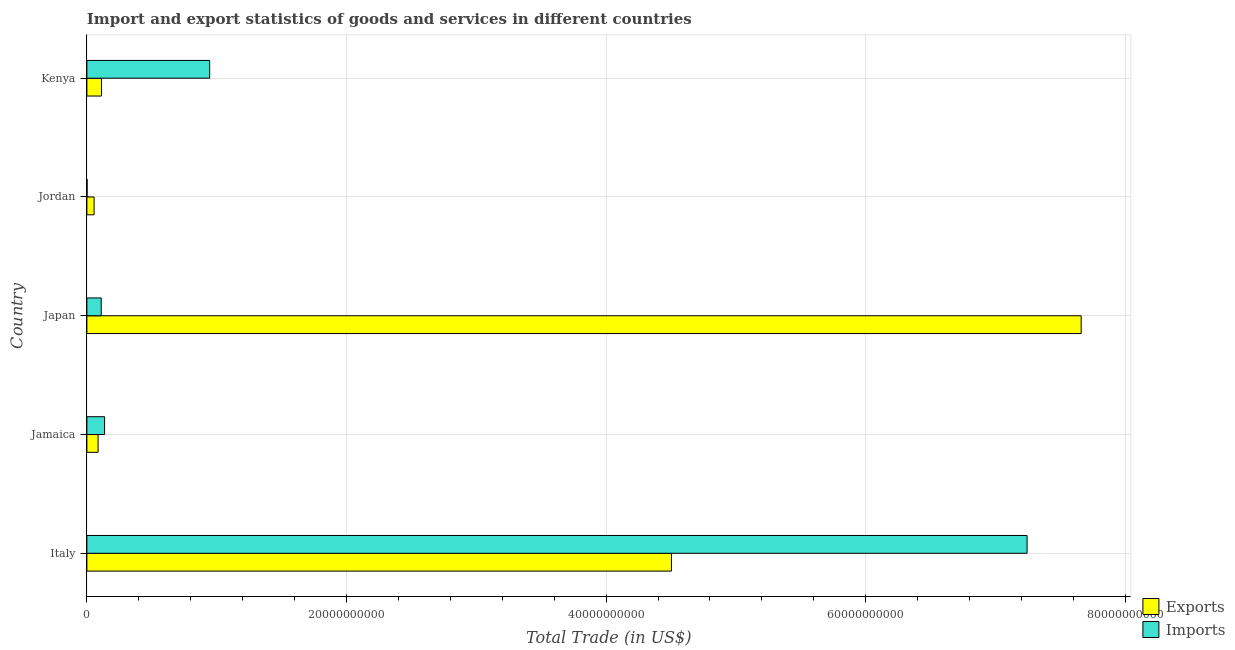How many different coloured bars are there?
Your answer should be compact. 2. What is the label of the 3rd group of bars from the top?
Offer a very short reply. Japan. What is the imports of goods and services in Jordan?
Ensure brevity in your answer.  1.47e+07. Across all countries, what is the maximum export of goods and services?
Offer a terse response. 7.66e+1. Across all countries, what is the minimum imports of goods and services?
Your answer should be compact. 1.47e+07. In which country was the imports of goods and services maximum?
Ensure brevity in your answer.  Italy. In which country was the export of goods and services minimum?
Keep it short and to the point. Jordan. What is the total imports of goods and services in the graph?
Provide a short and direct response. 8.44e+1. What is the difference between the imports of goods and services in Japan and that in Kenya?
Offer a very short reply. -8.36e+09. What is the difference between the export of goods and services in Japan and the imports of goods and services in Italy?
Offer a very short reply. 4.17e+09. What is the average export of goods and services per country?
Ensure brevity in your answer.  2.48e+1. What is the difference between the imports of goods and services and export of goods and services in Japan?
Give a very brief answer. -7.55e+1. In how many countries, is the imports of goods and services greater than 60000000000 US$?
Give a very brief answer. 1. What is the ratio of the imports of goods and services in Italy to that in Japan?
Ensure brevity in your answer.  65.65. Is the difference between the imports of goods and services in Jamaica and Kenya greater than the difference between the export of goods and services in Jamaica and Kenya?
Ensure brevity in your answer.  No. What is the difference between the highest and the second highest imports of goods and services?
Keep it short and to the point. 6.30e+1. What is the difference between the highest and the lowest imports of goods and services?
Provide a short and direct response. 7.24e+1. In how many countries, is the export of goods and services greater than the average export of goods and services taken over all countries?
Offer a very short reply. 2. What does the 2nd bar from the top in Italy represents?
Your answer should be very brief. Exports. What does the 2nd bar from the bottom in Jamaica represents?
Provide a short and direct response. Imports. Are all the bars in the graph horizontal?
Give a very brief answer. Yes. How many countries are there in the graph?
Your response must be concise. 5. Are the values on the major ticks of X-axis written in scientific E-notation?
Provide a succinct answer. No. Where does the legend appear in the graph?
Make the answer very short. Bottom right. How are the legend labels stacked?
Ensure brevity in your answer.  Vertical. What is the title of the graph?
Provide a short and direct response. Import and export statistics of goods and services in different countries. Does "Boys" appear as one of the legend labels in the graph?
Ensure brevity in your answer.  No. What is the label or title of the X-axis?
Keep it short and to the point. Total Trade (in US$). What is the Total Trade (in US$) of Exports in Italy?
Your response must be concise. 4.50e+1. What is the Total Trade (in US$) in Imports in Italy?
Your response must be concise. 7.24e+1. What is the Total Trade (in US$) in Exports in Jamaica?
Make the answer very short. 8.62e+08. What is the Total Trade (in US$) in Imports in Jamaica?
Offer a very short reply. 1.36e+09. What is the Total Trade (in US$) in Exports in Japan?
Offer a very short reply. 7.66e+1. What is the Total Trade (in US$) of Imports in Japan?
Provide a short and direct response. 1.10e+09. What is the Total Trade (in US$) in Exports in Jordan?
Your response must be concise. 5.53e+08. What is the Total Trade (in US$) of Imports in Jordan?
Your answer should be very brief. 1.47e+07. What is the Total Trade (in US$) of Exports in Kenya?
Ensure brevity in your answer.  1.13e+09. What is the Total Trade (in US$) of Imports in Kenya?
Your answer should be very brief. 9.46e+09. Across all countries, what is the maximum Total Trade (in US$) in Exports?
Your response must be concise. 7.66e+1. Across all countries, what is the maximum Total Trade (in US$) in Imports?
Offer a terse response. 7.24e+1. Across all countries, what is the minimum Total Trade (in US$) in Exports?
Your answer should be compact. 5.53e+08. Across all countries, what is the minimum Total Trade (in US$) in Imports?
Your answer should be very brief. 1.47e+07. What is the total Total Trade (in US$) of Exports in the graph?
Offer a very short reply. 1.24e+11. What is the total Total Trade (in US$) of Imports in the graph?
Ensure brevity in your answer.  8.44e+1. What is the difference between the Total Trade (in US$) in Exports in Italy and that in Jamaica?
Provide a short and direct response. 4.42e+1. What is the difference between the Total Trade (in US$) in Imports in Italy and that in Jamaica?
Your answer should be very brief. 7.11e+1. What is the difference between the Total Trade (in US$) in Exports in Italy and that in Japan?
Offer a very short reply. -3.16e+1. What is the difference between the Total Trade (in US$) of Imports in Italy and that in Japan?
Your response must be concise. 7.13e+1. What is the difference between the Total Trade (in US$) of Exports in Italy and that in Jordan?
Your answer should be compact. 4.45e+1. What is the difference between the Total Trade (in US$) in Imports in Italy and that in Jordan?
Your response must be concise. 7.24e+1. What is the difference between the Total Trade (in US$) of Exports in Italy and that in Kenya?
Provide a succinct answer. 4.39e+1. What is the difference between the Total Trade (in US$) of Imports in Italy and that in Kenya?
Offer a terse response. 6.30e+1. What is the difference between the Total Trade (in US$) in Exports in Jamaica and that in Japan?
Your answer should be very brief. -7.57e+1. What is the difference between the Total Trade (in US$) in Imports in Jamaica and that in Japan?
Offer a very short reply. 2.60e+08. What is the difference between the Total Trade (in US$) of Exports in Jamaica and that in Jordan?
Offer a very short reply. 3.08e+08. What is the difference between the Total Trade (in US$) of Imports in Jamaica and that in Jordan?
Give a very brief answer. 1.35e+09. What is the difference between the Total Trade (in US$) in Exports in Jamaica and that in Kenya?
Keep it short and to the point. -2.66e+08. What is the difference between the Total Trade (in US$) in Imports in Jamaica and that in Kenya?
Make the answer very short. -8.10e+09. What is the difference between the Total Trade (in US$) of Exports in Japan and that in Jordan?
Your answer should be very brief. 7.60e+1. What is the difference between the Total Trade (in US$) in Imports in Japan and that in Jordan?
Provide a short and direct response. 1.09e+09. What is the difference between the Total Trade (in US$) in Exports in Japan and that in Kenya?
Your answer should be compact. 7.55e+1. What is the difference between the Total Trade (in US$) of Imports in Japan and that in Kenya?
Offer a very short reply. -8.36e+09. What is the difference between the Total Trade (in US$) of Exports in Jordan and that in Kenya?
Make the answer very short. -5.74e+08. What is the difference between the Total Trade (in US$) of Imports in Jordan and that in Kenya?
Offer a very short reply. -9.45e+09. What is the difference between the Total Trade (in US$) in Exports in Italy and the Total Trade (in US$) in Imports in Jamaica?
Your answer should be compact. 4.37e+1. What is the difference between the Total Trade (in US$) of Exports in Italy and the Total Trade (in US$) of Imports in Japan?
Provide a short and direct response. 4.39e+1. What is the difference between the Total Trade (in US$) of Exports in Italy and the Total Trade (in US$) of Imports in Jordan?
Your answer should be compact. 4.50e+1. What is the difference between the Total Trade (in US$) in Exports in Italy and the Total Trade (in US$) in Imports in Kenya?
Provide a short and direct response. 3.56e+1. What is the difference between the Total Trade (in US$) in Exports in Jamaica and the Total Trade (in US$) in Imports in Japan?
Your answer should be compact. -2.42e+08. What is the difference between the Total Trade (in US$) of Exports in Jamaica and the Total Trade (in US$) of Imports in Jordan?
Provide a succinct answer. 8.47e+08. What is the difference between the Total Trade (in US$) of Exports in Jamaica and the Total Trade (in US$) of Imports in Kenya?
Your answer should be very brief. -8.60e+09. What is the difference between the Total Trade (in US$) in Exports in Japan and the Total Trade (in US$) in Imports in Jordan?
Your answer should be very brief. 7.66e+1. What is the difference between the Total Trade (in US$) of Exports in Japan and the Total Trade (in US$) of Imports in Kenya?
Ensure brevity in your answer.  6.71e+1. What is the difference between the Total Trade (in US$) of Exports in Jordan and the Total Trade (in US$) of Imports in Kenya?
Provide a succinct answer. -8.91e+09. What is the average Total Trade (in US$) in Exports per country?
Keep it short and to the point. 2.48e+1. What is the average Total Trade (in US$) in Imports per country?
Ensure brevity in your answer.  1.69e+1. What is the difference between the Total Trade (in US$) in Exports and Total Trade (in US$) in Imports in Italy?
Your answer should be very brief. -2.74e+1. What is the difference between the Total Trade (in US$) in Exports and Total Trade (in US$) in Imports in Jamaica?
Your answer should be very brief. -5.02e+08. What is the difference between the Total Trade (in US$) of Exports and Total Trade (in US$) of Imports in Japan?
Make the answer very short. 7.55e+1. What is the difference between the Total Trade (in US$) of Exports and Total Trade (in US$) of Imports in Jordan?
Offer a very short reply. 5.39e+08. What is the difference between the Total Trade (in US$) of Exports and Total Trade (in US$) of Imports in Kenya?
Offer a very short reply. -8.33e+09. What is the ratio of the Total Trade (in US$) in Exports in Italy to that in Jamaica?
Offer a very short reply. 52.27. What is the ratio of the Total Trade (in US$) of Imports in Italy to that in Jamaica?
Your answer should be compact. 53.14. What is the ratio of the Total Trade (in US$) in Exports in Italy to that in Japan?
Ensure brevity in your answer.  0.59. What is the ratio of the Total Trade (in US$) in Imports in Italy to that in Japan?
Offer a very short reply. 65.65. What is the ratio of the Total Trade (in US$) of Exports in Italy to that in Jordan?
Offer a terse response. 81.39. What is the ratio of the Total Trade (in US$) in Imports in Italy to that in Jordan?
Your answer should be very brief. 4935.4. What is the ratio of the Total Trade (in US$) in Exports in Italy to that in Kenya?
Your response must be concise. 39.94. What is the ratio of the Total Trade (in US$) of Imports in Italy to that in Kenya?
Provide a short and direct response. 7.66. What is the ratio of the Total Trade (in US$) in Exports in Jamaica to that in Japan?
Provide a short and direct response. 0.01. What is the ratio of the Total Trade (in US$) of Imports in Jamaica to that in Japan?
Give a very brief answer. 1.24. What is the ratio of the Total Trade (in US$) in Exports in Jamaica to that in Jordan?
Give a very brief answer. 1.56. What is the ratio of the Total Trade (in US$) in Imports in Jamaica to that in Jordan?
Offer a very short reply. 92.87. What is the ratio of the Total Trade (in US$) in Exports in Jamaica to that in Kenya?
Give a very brief answer. 0.76. What is the ratio of the Total Trade (in US$) of Imports in Jamaica to that in Kenya?
Keep it short and to the point. 0.14. What is the ratio of the Total Trade (in US$) of Exports in Japan to that in Jordan?
Offer a terse response. 138.43. What is the ratio of the Total Trade (in US$) in Imports in Japan to that in Jordan?
Provide a short and direct response. 75.18. What is the ratio of the Total Trade (in US$) of Exports in Japan to that in Kenya?
Offer a terse response. 67.94. What is the ratio of the Total Trade (in US$) in Imports in Japan to that in Kenya?
Provide a succinct answer. 0.12. What is the ratio of the Total Trade (in US$) in Exports in Jordan to that in Kenya?
Your answer should be very brief. 0.49. What is the ratio of the Total Trade (in US$) in Imports in Jordan to that in Kenya?
Keep it short and to the point. 0. What is the difference between the highest and the second highest Total Trade (in US$) of Exports?
Your answer should be compact. 3.16e+1. What is the difference between the highest and the second highest Total Trade (in US$) of Imports?
Offer a very short reply. 6.30e+1. What is the difference between the highest and the lowest Total Trade (in US$) of Exports?
Your answer should be very brief. 7.60e+1. What is the difference between the highest and the lowest Total Trade (in US$) of Imports?
Your response must be concise. 7.24e+1. 